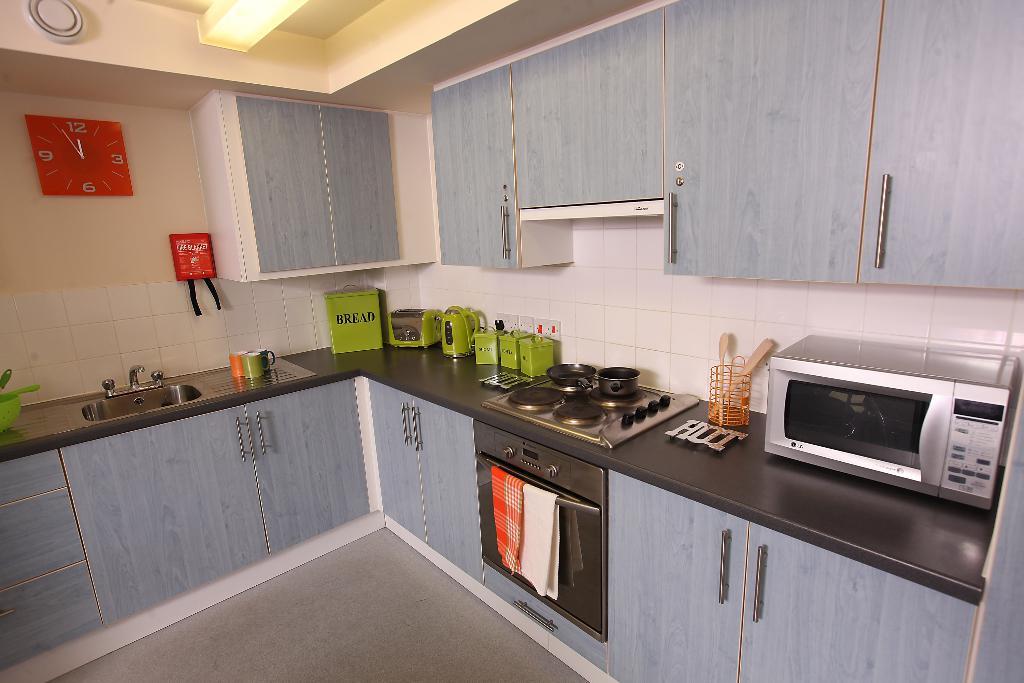What word is on the green canister?
Your response must be concise. Bread. 